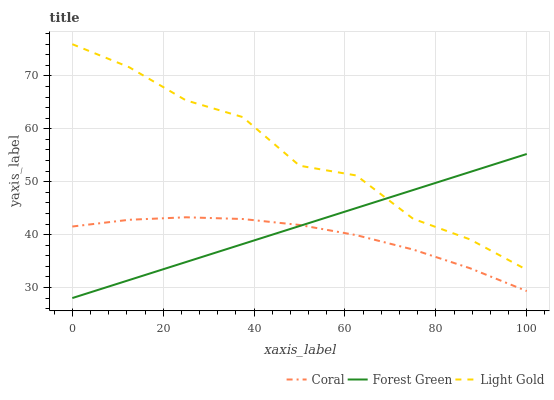Does Coral have the minimum area under the curve?
Answer yes or no. Yes. Does Light Gold have the maximum area under the curve?
Answer yes or no. Yes. Does Forest Green have the minimum area under the curve?
Answer yes or no. No. Does Forest Green have the maximum area under the curve?
Answer yes or no. No. Is Forest Green the smoothest?
Answer yes or no. Yes. Is Light Gold the roughest?
Answer yes or no. Yes. Is Light Gold the smoothest?
Answer yes or no. No. Is Forest Green the roughest?
Answer yes or no. No. Does Forest Green have the lowest value?
Answer yes or no. Yes. Does Light Gold have the lowest value?
Answer yes or no. No. Does Light Gold have the highest value?
Answer yes or no. Yes. Does Forest Green have the highest value?
Answer yes or no. No. Is Coral less than Light Gold?
Answer yes or no. Yes. Is Light Gold greater than Coral?
Answer yes or no. Yes. Does Coral intersect Forest Green?
Answer yes or no. Yes. Is Coral less than Forest Green?
Answer yes or no. No. Is Coral greater than Forest Green?
Answer yes or no. No. Does Coral intersect Light Gold?
Answer yes or no. No. 